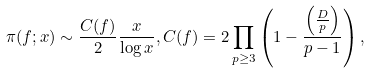<formula> <loc_0><loc_0><loc_500><loc_500>\pi ( f ; x ) \sim \frac { C ( f ) } { 2 } \frac { x } { \log { x } } , C ( f ) = 2 \prod _ { p \geq 3 } \left ( 1 - \frac { \left ( \frac { D } { p } \right ) } { p - 1 } \right ) ,</formula> 